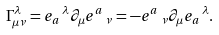Convert formula to latex. <formula><loc_0><loc_0><loc_500><loc_500>\Gamma _ { \mu \nu } ^ { \lambda } = e _ { a } \, ^ { \lambda } \partial _ { \mu } e ^ { a } \, _ { \nu } = - e ^ { a } \, _ { \nu } \partial _ { \mu } e _ { a } \, ^ { \lambda } .</formula> 